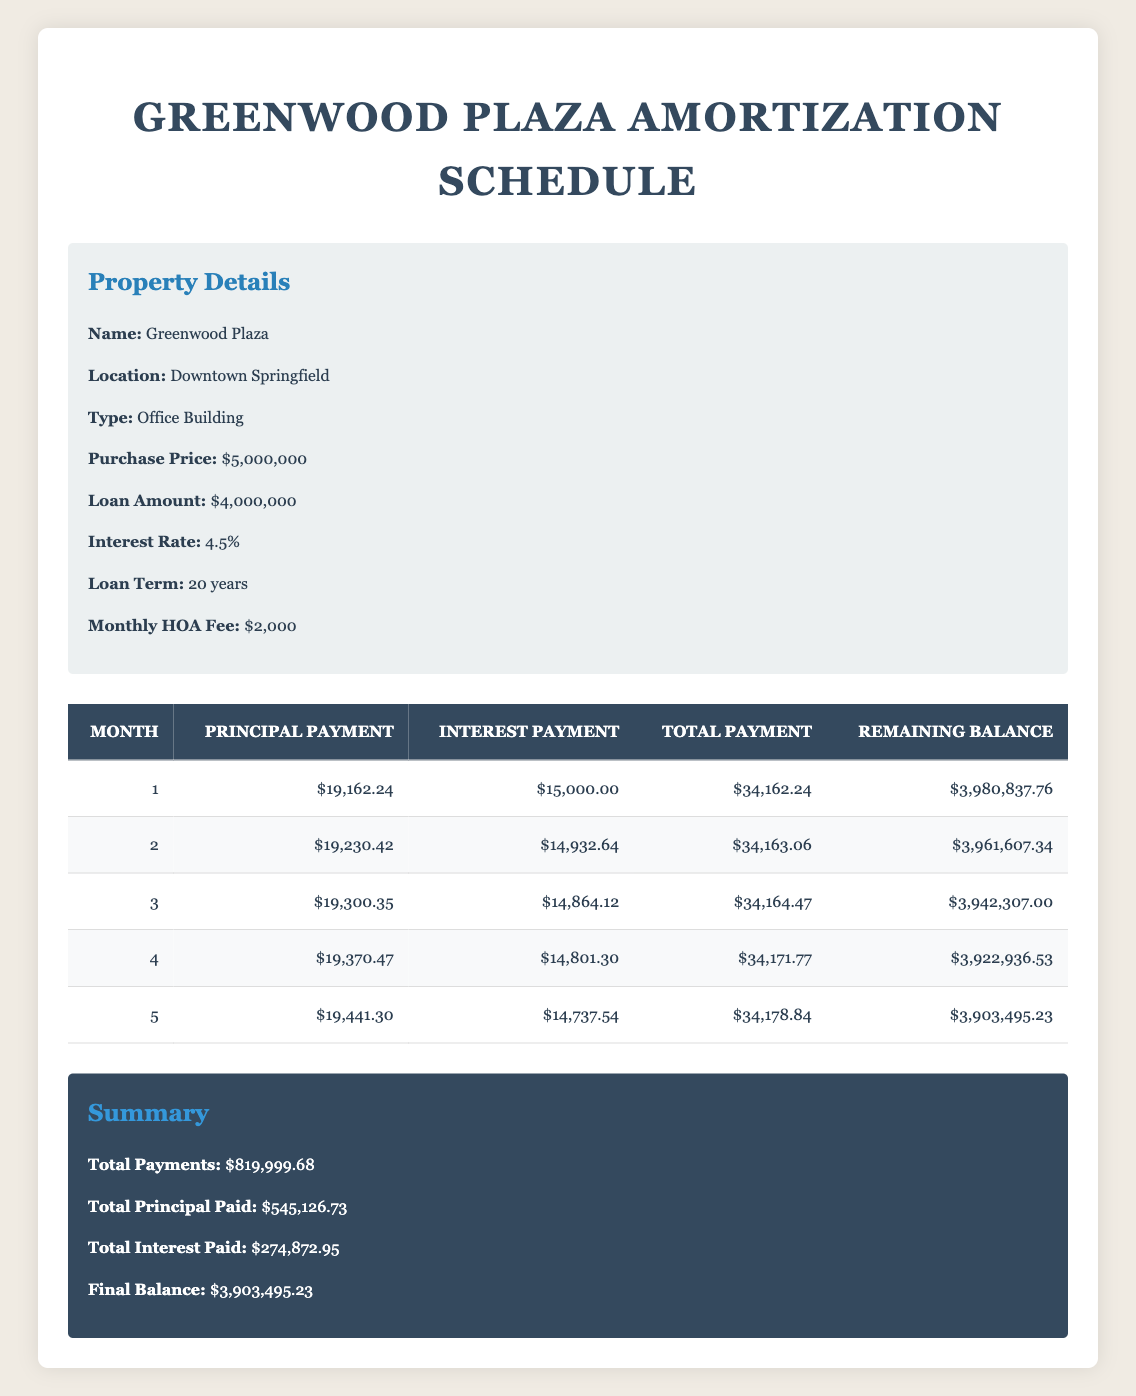What is the total principal payment made in the first month? The total principal payment for the first month is listed directly in the table under principal payment for month 1, which is 19162.24.
Answer: 19162.24 What was the interest payment in the third month? The interest payment for the third month is provided in the table under interest payment for month 3, which is 14864.12.
Answer: 14864.12 What is the average total payment over the first five months? To find the average total payment, first sum the total payments of the first five months: 34162.24 + 34163.06 + 34164.47 + 34171.77 + 34178.84 = 170940.38. Then, divide by 5: 170940.38/5 = 34188.08.
Answer: 34188.08 What is the total interest paid after five months? The total interest paid after five months involves summing the interest payments from the first five months: 15000.00 + 14932.64 + 14864.12 + 14801.30 + 14737.54 = 74335.60.
Answer: 74335.60 Is the total payment in the first month greater than the total payment in the second month? By comparing the total payments, the first month total payment is 34162.24 and the second month total payment is 34163.06. Since 34162.24 is less than 34163.06, the statement is false.
Answer: No What remains as the loan balance after the first month? The remaining balance after the first month is shown in the table under the remaining balance for month 1, which is 3980837.76.
Answer: 3980837.76 By how much does the principal payment increase from the first month to the second month? The principal payment for the first month is 19162.24, and for the second month, it is 19230.42. The increase is 19230.42 - 19162.24 = 68.18.
Answer: 68.18 What is the total amount paid, including interest, after five months? To find the total paid including interest after five months, sum the total payments for the first five months: 34162.24 + 34163.06 + 34164.47 + 34171.77 + 34178.84 = 170940.38.
Answer: 170940.38 Has more than half of the total loan amount been paid off after five months? The total loan amount is 4000000. After five months, the total principal paid is 545126.73. Half of 4000000 is 2000000, and since 545126.73 is less than that, the answer is no.
Answer: No 